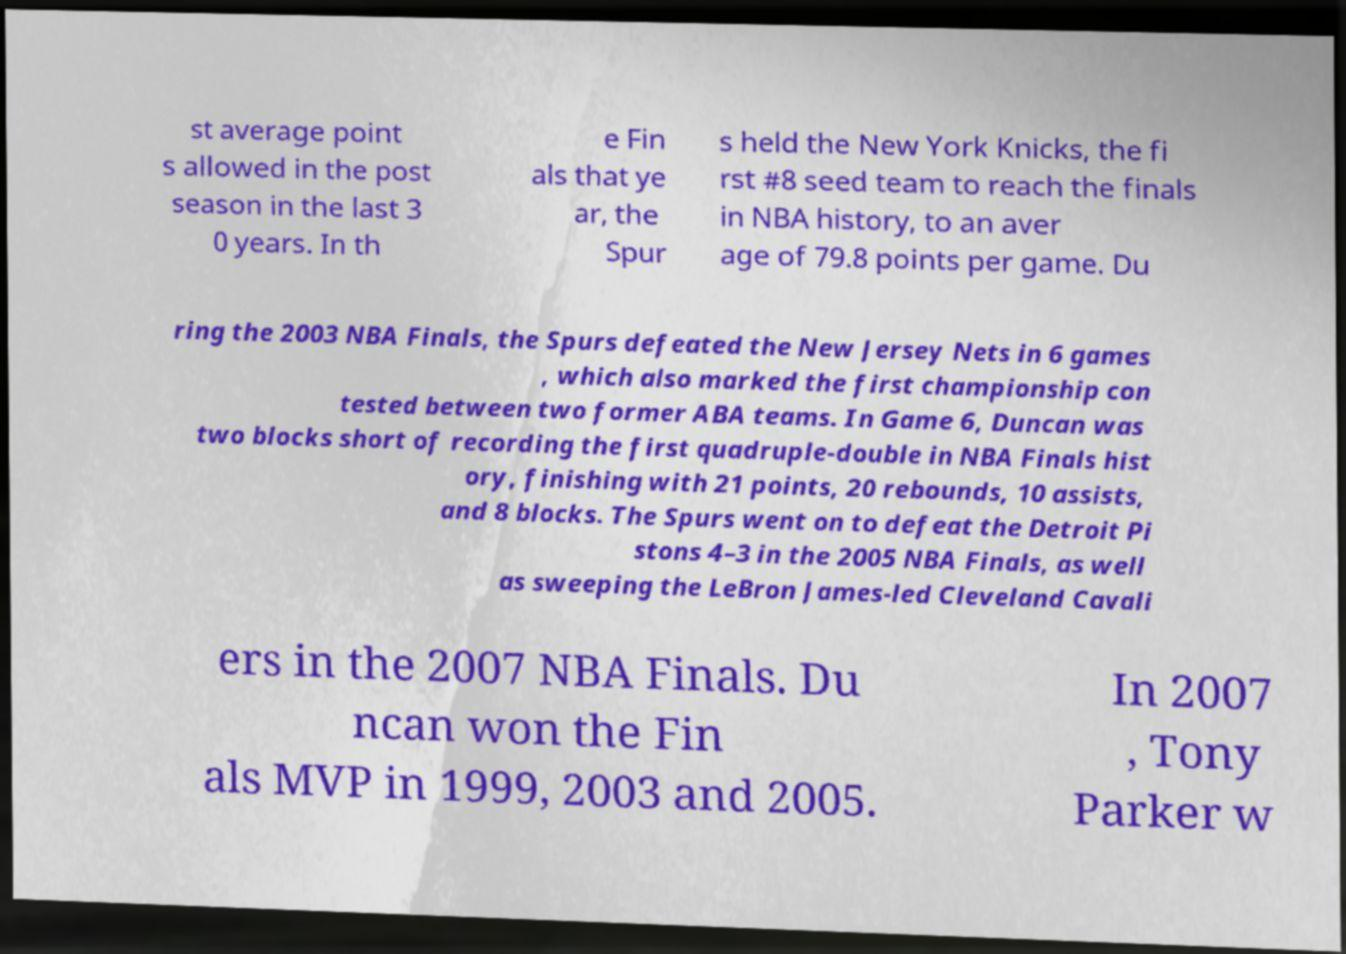I need the written content from this picture converted into text. Can you do that? st average point s allowed in the post season in the last 3 0 years. In th e Fin als that ye ar, the Spur s held the New York Knicks, the fi rst #8 seed team to reach the finals in NBA history, to an aver age of 79.8 points per game. Du ring the 2003 NBA Finals, the Spurs defeated the New Jersey Nets in 6 games , which also marked the first championship con tested between two former ABA teams. In Game 6, Duncan was two blocks short of recording the first quadruple-double in NBA Finals hist ory, finishing with 21 points, 20 rebounds, 10 assists, and 8 blocks. The Spurs went on to defeat the Detroit Pi stons 4–3 in the 2005 NBA Finals, as well as sweeping the LeBron James-led Cleveland Cavali ers in the 2007 NBA Finals. Du ncan won the Fin als MVP in 1999, 2003 and 2005. In 2007 , Tony Parker w 